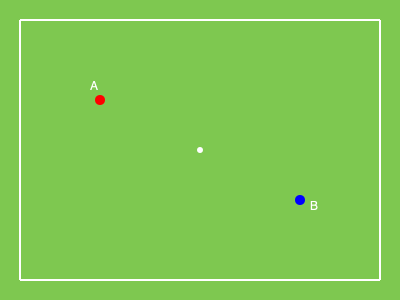On a scaled soccer pitch diagram, Player A is positioned at coordinates (100, 100) and Player B at (300, 200). If the actual pitch dimensions are 100m x 75m, what is the approximate real-world distance between these two players? To solve this problem, we'll follow these steps:

1. Determine the scale of the diagram:
   - The diagram is 360 units wide (380 - 20) and 260 units tall (280 - 20)
   - The actual pitch is 100m x 75m
   - Scale: 360 units = 100m, 260 units = 75m

2. Calculate the horizontal and vertical distances between players:
   - Horizontal distance: 300 - 100 = 200 units
   - Vertical distance: 200 - 100 = 100 units

3. Convert these distances to real-world measurements:
   - Horizontal: $\frac{200}{360} \times 100m = \frac{5000}{9}m \approx 55.56m$
   - Vertical: $\frac{100}{260} \times 75m = \frac{2885}{104}m \approx 28.85m$

4. Use the Pythagorean theorem to calculate the direct distance:
   $d = \sqrt{(55.56)^2 + (28.85)^2}$
   $d = \sqrt{3086.9136 + 832.3225}$
   $d = \sqrt{3919.2361}$
   $d \approx 62.60m$

Therefore, the approximate real-world distance between Players A and B is 62.60 meters.
Answer: 62.60 meters 